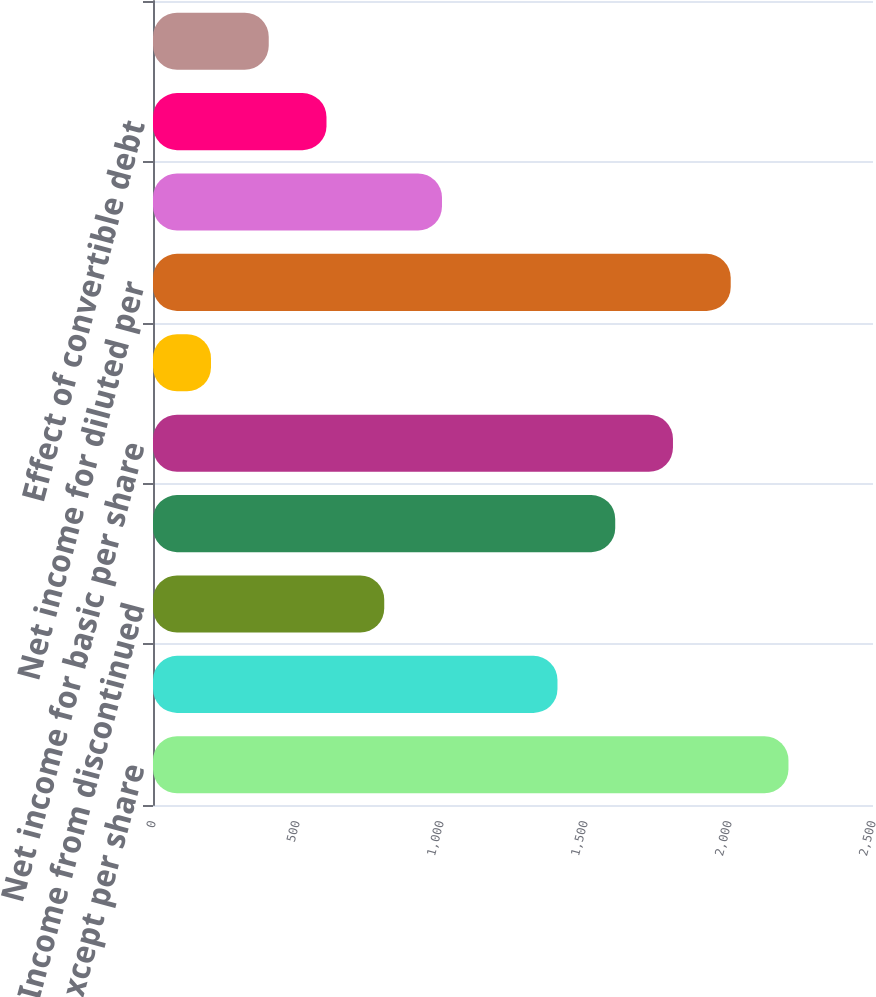Convert chart. <chart><loc_0><loc_0><loc_500><loc_500><bar_chart><fcel>(millions except per share<fcel>Income from continuing<fcel>Income from discontinued<fcel>Net income<fcel>Net income for basic per share<fcel>Interest expense on<fcel>Net income for diluted per<fcel>Basic shares outstanding<fcel>Effect of convertible debt<fcel>Common stock equivalents<nl><fcel>2206.47<fcel>1404.43<fcel>802.9<fcel>1604.94<fcel>1805.45<fcel>201.37<fcel>2005.96<fcel>1003.41<fcel>602.39<fcel>401.88<nl></chart> 